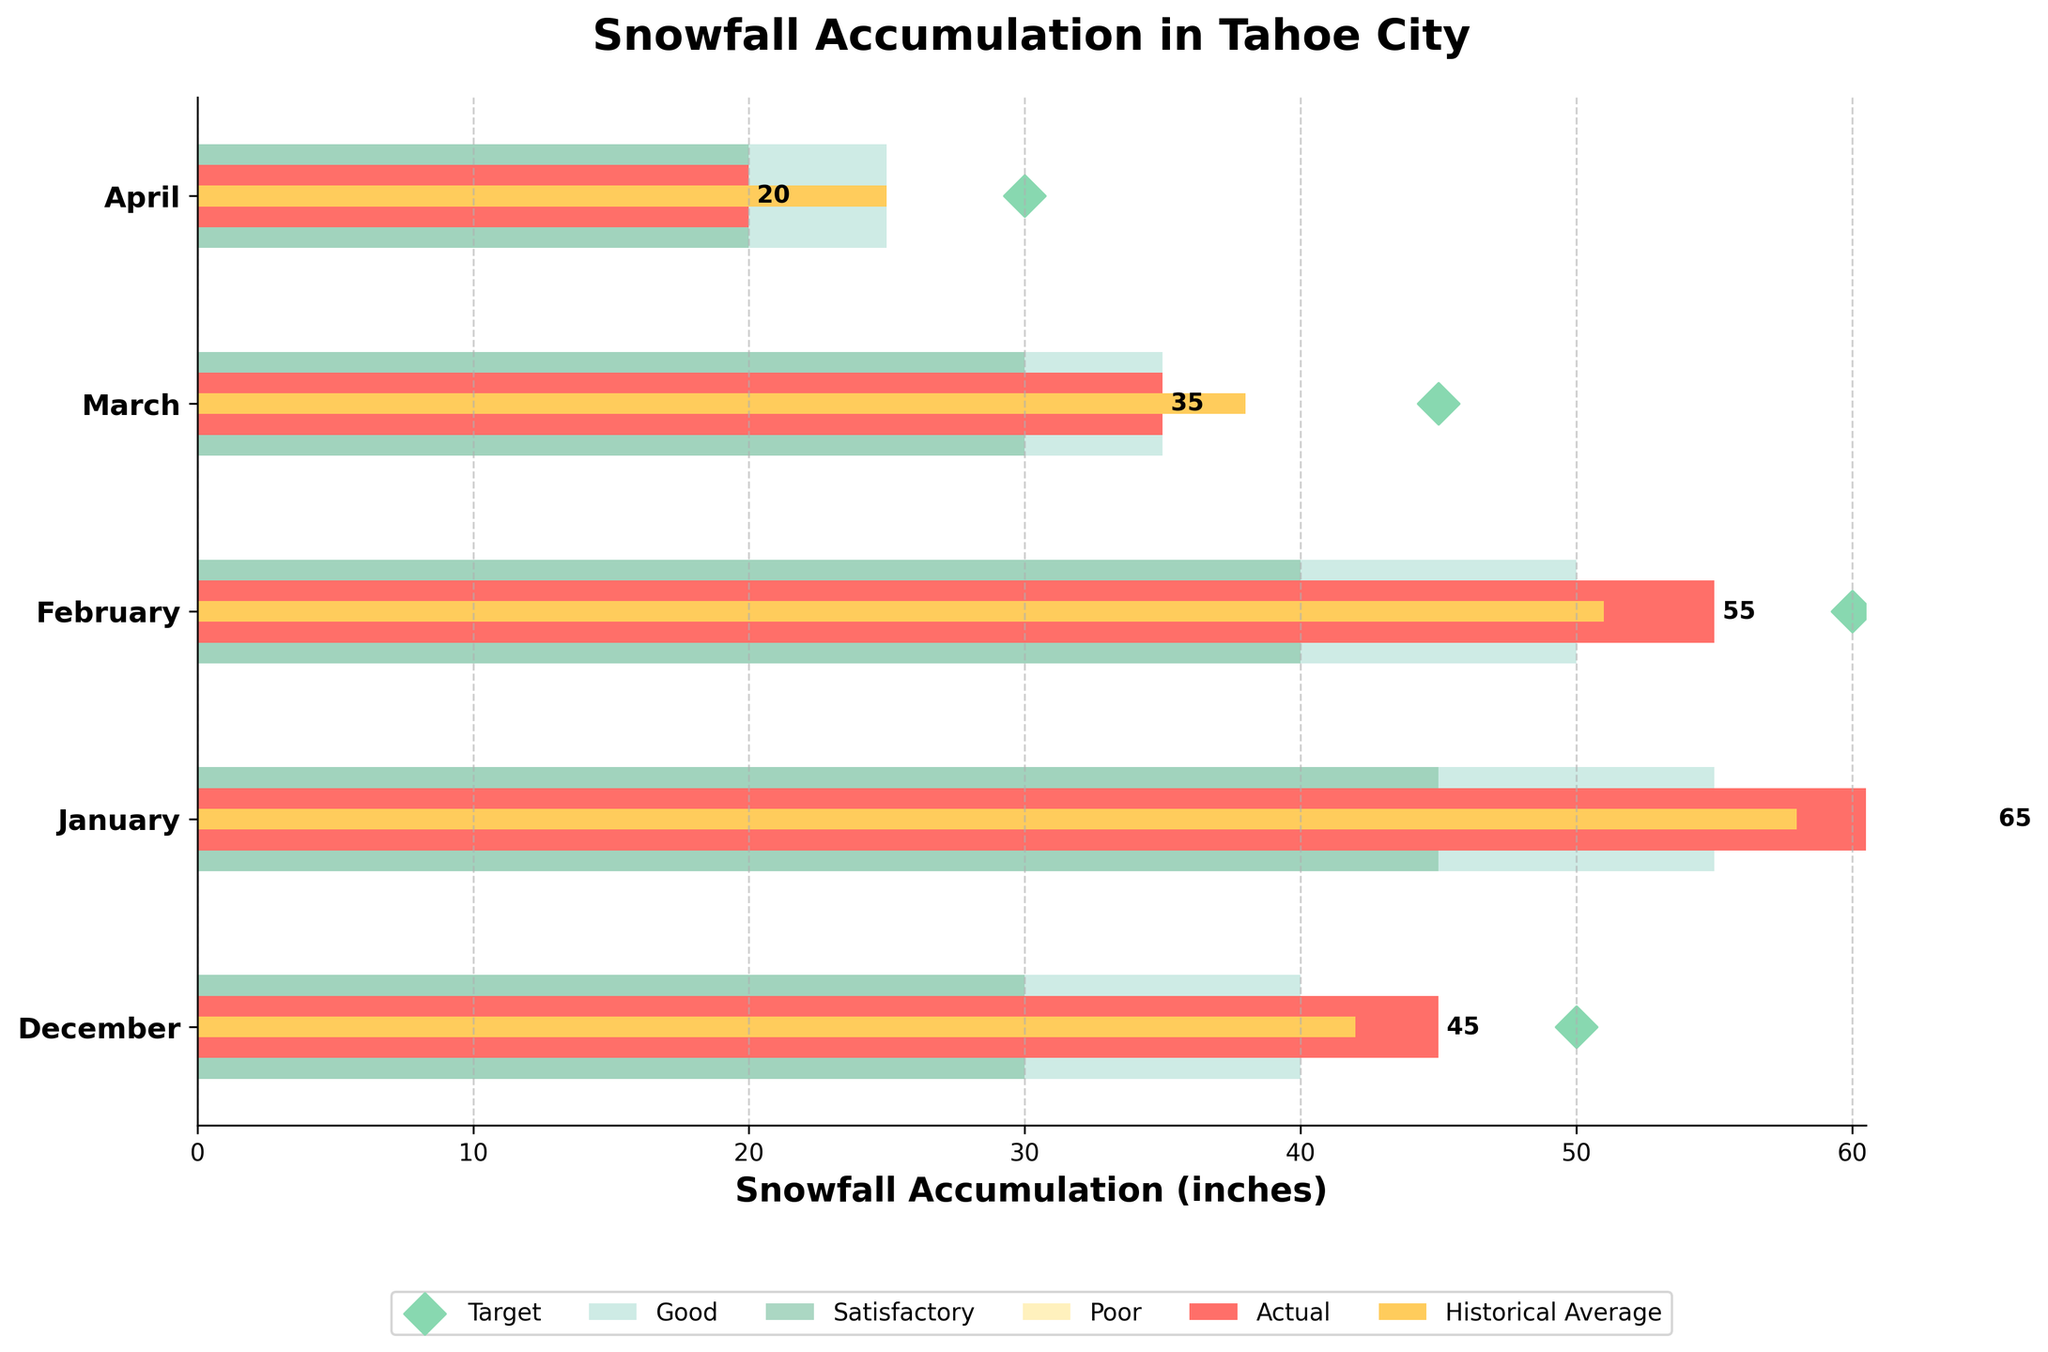What's the title of the chart? The title is usually located at the top of the chart, above the main data visualization area. In this case, the title provided in the code is "Snowfall Accumulation in Tahoe City".
Answer: Snowfall Accumulation in Tahoe City What does the orange bar represent? The orange bar represents the historical average snowfall accumulation for each month. This is indicated by the color and height of the bars that are thinner compared to the actual snowfall bars.
Answer: Historical average How many months are displayed in the chart? The chart has distinct horizontal bars for each month, indicated by the categorical labels on the y-axis. These labels list the months observed: December, January, February, March, and April.
Answer: 5 Which month had the highest actual snowfall accumulation? To find this, we compare the length of the red bars (representing actual snowfall) for all months. January's bar is the longest, representing the highest snowfall.
Answer: January In which month is snowfall accumulation below the historical average? A comparison between the red bars (actual snowfall) and the orange bars (historical average) shows if actual snowfall is less. In March and April, the actual snowfall (red bars) is below the historical average (orange bars).
Answer: March, April What months met or exceeded the target snowfall accumulation? The target snowfall markers (green diamonds) indicate the target for each month. Comparing these with actual snowfall (red bars), January met its target, as the red bar reaches or passes the green diamond.
Answer: January Which month had the smallest actual snowfall compared to the historical average? Subtract the historical average from the actual snowfall for each month. The month with the smallest value is where the discrepancy is highest. In this case, April has the biggest negative difference, 20-25 = -5.
Answer: April For which months is the actual snowfall deemed 'Good'? Actual snowfall is represented by red bars, and 'Good' ranges are illustrated by background bars in a greenish color. Both January (65) and December (45) fall into this 'Good' range.
Answer: December, January Compare the actual snowfall in February and March. How much more or less was snowfall in February compared to March? February's actual snowfall is 55 inches, and March's is 35 inches. Subtract March's value from February's to find the difference, 55 - 35 = 20 inches more in February.
Answer: 20 inches more Which month is closest to meeting the satisfactory level of snowfall accumulation? Compare actual snowfall (red bars) to the 'Satisfactory' range (mid-green section). March, with an actual snowfall close to the satisfactory threshold (35 inches), is the closest without exceeding it.
Answer: March 